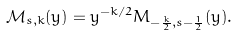Convert formula to latex. <formula><loc_0><loc_0><loc_500><loc_500>\mathcal { M } _ { s , k } ( y ) = y ^ { - k / 2 } M _ { - \frac { k } { 2 } , s - \frac { 1 } { 2 } } ( y ) .</formula> 